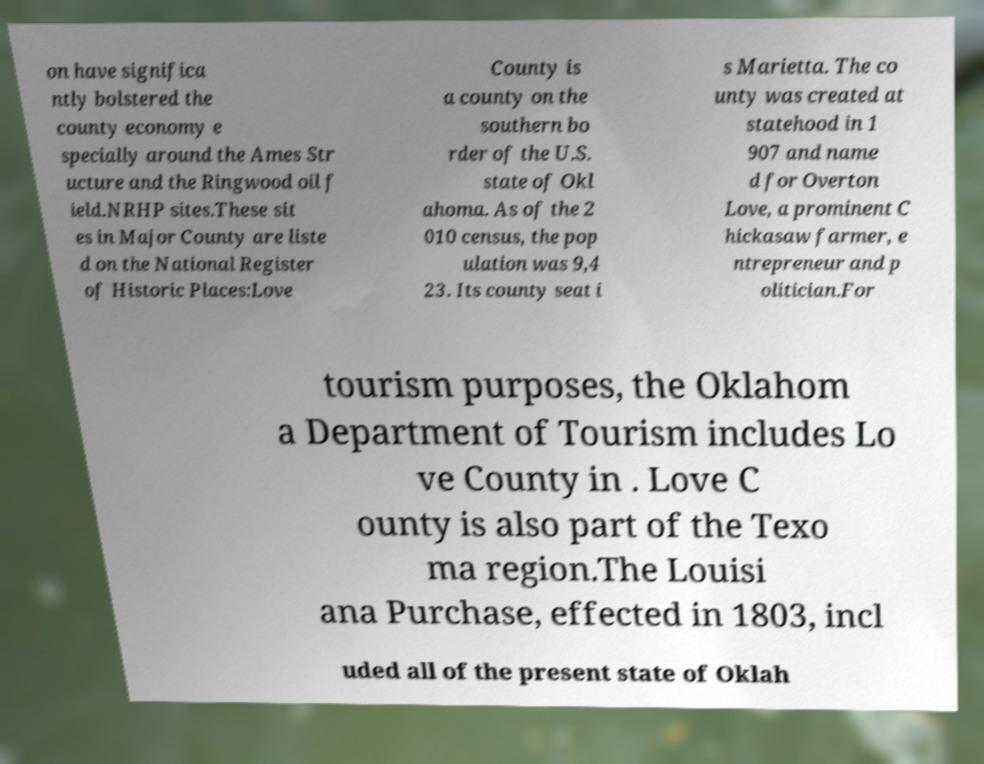For documentation purposes, I need the text within this image transcribed. Could you provide that? on have significa ntly bolstered the county economy e specially around the Ames Str ucture and the Ringwood oil f ield.NRHP sites.These sit es in Major County are liste d on the National Register of Historic Places:Love County is a county on the southern bo rder of the U.S. state of Okl ahoma. As of the 2 010 census, the pop ulation was 9,4 23. Its county seat i s Marietta. The co unty was created at statehood in 1 907 and name d for Overton Love, a prominent C hickasaw farmer, e ntrepreneur and p olitician.For tourism purposes, the Oklahom a Department of Tourism includes Lo ve County in . Love C ounty is also part of the Texo ma region.The Louisi ana Purchase, effected in 1803, incl uded all of the present state of Oklah 